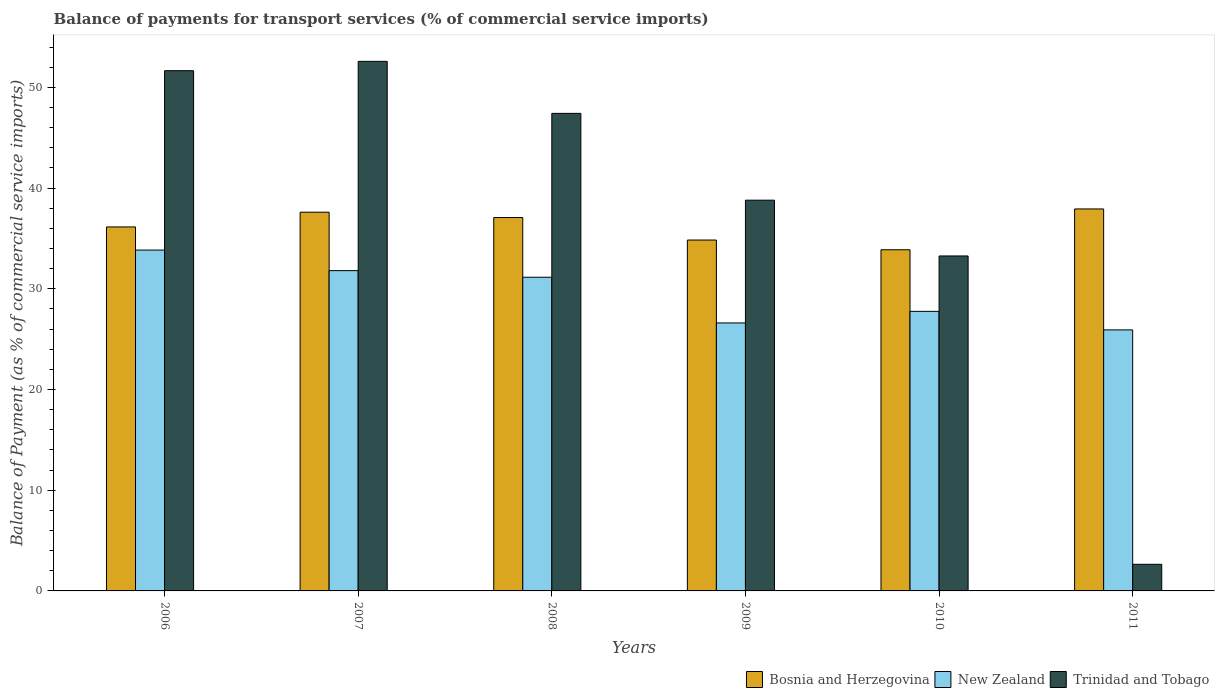How many different coloured bars are there?
Offer a terse response. 3. How many bars are there on the 3rd tick from the left?
Provide a succinct answer. 3. How many bars are there on the 3rd tick from the right?
Your response must be concise. 3. What is the label of the 6th group of bars from the left?
Offer a very short reply. 2011. What is the balance of payments for transport services in Bosnia and Herzegovina in 2010?
Provide a short and direct response. 33.88. Across all years, what is the maximum balance of payments for transport services in New Zealand?
Your response must be concise. 33.85. Across all years, what is the minimum balance of payments for transport services in New Zealand?
Offer a terse response. 25.92. What is the total balance of payments for transport services in New Zealand in the graph?
Offer a very short reply. 177.09. What is the difference between the balance of payments for transport services in New Zealand in 2006 and that in 2010?
Your response must be concise. 6.09. What is the difference between the balance of payments for transport services in New Zealand in 2007 and the balance of payments for transport services in Trinidad and Tobago in 2006?
Your answer should be compact. -19.85. What is the average balance of payments for transport services in Trinidad and Tobago per year?
Provide a succinct answer. 37.73. In the year 2010, what is the difference between the balance of payments for transport services in Trinidad and Tobago and balance of payments for transport services in Bosnia and Herzegovina?
Make the answer very short. -0.61. What is the ratio of the balance of payments for transport services in Bosnia and Herzegovina in 2006 to that in 2011?
Offer a terse response. 0.95. What is the difference between the highest and the second highest balance of payments for transport services in New Zealand?
Your response must be concise. 2.04. What is the difference between the highest and the lowest balance of payments for transport services in Trinidad and Tobago?
Your answer should be very brief. 49.94. Is the sum of the balance of payments for transport services in Trinidad and Tobago in 2007 and 2008 greater than the maximum balance of payments for transport services in Bosnia and Herzegovina across all years?
Your response must be concise. Yes. What does the 2nd bar from the left in 2010 represents?
Give a very brief answer. New Zealand. What does the 1st bar from the right in 2007 represents?
Make the answer very short. Trinidad and Tobago. How many bars are there?
Your answer should be very brief. 18. Are all the bars in the graph horizontal?
Give a very brief answer. No. How many years are there in the graph?
Make the answer very short. 6. Are the values on the major ticks of Y-axis written in scientific E-notation?
Offer a very short reply. No. Does the graph contain grids?
Provide a succinct answer. No. Where does the legend appear in the graph?
Give a very brief answer. Bottom right. How are the legend labels stacked?
Offer a terse response. Horizontal. What is the title of the graph?
Provide a succinct answer. Balance of payments for transport services (% of commercial service imports). What is the label or title of the X-axis?
Keep it short and to the point. Years. What is the label or title of the Y-axis?
Give a very brief answer. Balance of Payment (as % of commercial service imports). What is the Balance of Payment (as % of commercial service imports) in Bosnia and Herzegovina in 2006?
Make the answer very short. 36.14. What is the Balance of Payment (as % of commercial service imports) in New Zealand in 2006?
Ensure brevity in your answer.  33.85. What is the Balance of Payment (as % of commercial service imports) in Trinidad and Tobago in 2006?
Make the answer very short. 51.66. What is the Balance of Payment (as % of commercial service imports) of Bosnia and Herzegovina in 2007?
Your answer should be very brief. 37.6. What is the Balance of Payment (as % of commercial service imports) of New Zealand in 2007?
Offer a terse response. 31.8. What is the Balance of Payment (as % of commercial service imports) of Trinidad and Tobago in 2007?
Provide a short and direct response. 52.58. What is the Balance of Payment (as % of commercial service imports) in Bosnia and Herzegovina in 2008?
Offer a terse response. 37.08. What is the Balance of Payment (as % of commercial service imports) of New Zealand in 2008?
Ensure brevity in your answer.  31.15. What is the Balance of Payment (as % of commercial service imports) of Trinidad and Tobago in 2008?
Provide a succinct answer. 47.42. What is the Balance of Payment (as % of commercial service imports) of Bosnia and Herzegovina in 2009?
Provide a succinct answer. 34.84. What is the Balance of Payment (as % of commercial service imports) in New Zealand in 2009?
Provide a short and direct response. 26.61. What is the Balance of Payment (as % of commercial service imports) of Trinidad and Tobago in 2009?
Make the answer very short. 38.8. What is the Balance of Payment (as % of commercial service imports) of Bosnia and Herzegovina in 2010?
Your answer should be compact. 33.88. What is the Balance of Payment (as % of commercial service imports) of New Zealand in 2010?
Give a very brief answer. 27.76. What is the Balance of Payment (as % of commercial service imports) in Trinidad and Tobago in 2010?
Offer a very short reply. 33.26. What is the Balance of Payment (as % of commercial service imports) of Bosnia and Herzegovina in 2011?
Your response must be concise. 37.93. What is the Balance of Payment (as % of commercial service imports) of New Zealand in 2011?
Ensure brevity in your answer.  25.92. What is the Balance of Payment (as % of commercial service imports) of Trinidad and Tobago in 2011?
Your answer should be very brief. 2.64. Across all years, what is the maximum Balance of Payment (as % of commercial service imports) in Bosnia and Herzegovina?
Offer a very short reply. 37.93. Across all years, what is the maximum Balance of Payment (as % of commercial service imports) of New Zealand?
Make the answer very short. 33.85. Across all years, what is the maximum Balance of Payment (as % of commercial service imports) of Trinidad and Tobago?
Your response must be concise. 52.58. Across all years, what is the minimum Balance of Payment (as % of commercial service imports) in Bosnia and Herzegovina?
Provide a short and direct response. 33.88. Across all years, what is the minimum Balance of Payment (as % of commercial service imports) in New Zealand?
Provide a succinct answer. 25.92. Across all years, what is the minimum Balance of Payment (as % of commercial service imports) of Trinidad and Tobago?
Your answer should be compact. 2.64. What is the total Balance of Payment (as % of commercial service imports) of Bosnia and Herzegovina in the graph?
Your answer should be very brief. 217.47. What is the total Balance of Payment (as % of commercial service imports) in New Zealand in the graph?
Your answer should be very brief. 177.09. What is the total Balance of Payment (as % of commercial service imports) of Trinidad and Tobago in the graph?
Your answer should be compact. 226.37. What is the difference between the Balance of Payment (as % of commercial service imports) of Bosnia and Herzegovina in 2006 and that in 2007?
Your answer should be compact. -1.46. What is the difference between the Balance of Payment (as % of commercial service imports) in New Zealand in 2006 and that in 2007?
Make the answer very short. 2.04. What is the difference between the Balance of Payment (as % of commercial service imports) in Trinidad and Tobago in 2006 and that in 2007?
Keep it short and to the point. -0.93. What is the difference between the Balance of Payment (as % of commercial service imports) of Bosnia and Herzegovina in 2006 and that in 2008?
Keep it short and to the point. -0.93. What is the difference between the Balance of Payment (as % of commercial service imports) of New Zealand in 2006 and that in 2008?
Provide a short and direct response. 2.7. What is the difference between the Balance of Payment (as % of commercial service imports) in Trinidad and Tobago in 2006 and that in 2008?
Offer a terse response. 4.24. What is the difference between the Balance of Payment (as % of commercial service imports) in Bosnia and Herzegovina in 2006 and that in 2009?
Your response must be concise. 1.3. What is the difference between the Balance of Payment (as % of commercial service imports) of New Zealand in 2006 and that in 2009?
Ensure brevity in your answer.  7.24. What is the difference between the Balance of Payment (as % of commercial service imports) in Trinidad and Tobago in 2006 and that in 2009?
Offer a terse response. 12.86. What is the difference between the Balance of Payment (as % of commercial service imports) of Bosnia and Herzegovina in 2006 and that in 2010?
Your answer should be very brief. 2.27. What is the difference between the Balance of Payment (as % of commercial service imports) in New Zealand in 2006 and that in 2010?
Your response must be concise. 6.09. What is the difference between the Balance of Payment (as % of commercial service imports) of Trinidad and Tobago in 2006 and that in 2010?
Provide a short and direct response. 18.4. What is the difference between the Balance of Payment (as % of commercial service imports) in Bosnia and Herzegovina in 2006 and that in 2011?
Keep it short and to the point. -1.79. What is the difference between the Balance of Payment (as % of commercial service imports) of New Zealand in 2006 and that in 2011?
Provide a short and direct response. 7.93. What is the difference between the Balance of Payment (as % of commercial service imports) of Trinidad and Tobago in 2006 and that in 2011?
Your response must be concise. 49.02. What is the difference between the Balance of Payment (as % of commercial service imports) of Bosnia and Herzegovina in 2007 and that in 2008?
Give a very brief answer. 0.53. What is the difference between the Balance of Payment (as % of commercial service imports) of New Zealand in 2007 and that in 2008?
Your response must be concise. 0.66. What is the difference between the Balance of Payment (as % of commercial service imports) in Trinidad and Tobago in 2007 and that in 2008?
Give a very brief answer. 5.16. What is the difference between the Balance of Payment (as % of commercial service imports) of Bosnia and Herzegovina in 2007 and that in 2009?
Ensure brevity in your answer.  2.76. What is the difference between the Balance of Payment (as % of commercial service imports) of New Zealand in 2007 and that in 2009?
Provide a short and direct response. 5.2. What is the difference between the Balance of Payment (as % of commercial service imports) in Trinidad and Tobago in 2007 and that in 2009?
Offer a terse response. 13.79. What is the difference between the Balance of Payment (as % of commercial service imports) in Bosnia and Herzegovina in 2007 and that in 2010?
Give a very brief answer. 3.73. What is the difference between the Balance of Payment (as % of commercial service imports) of New Zealand in 2007 and that in 2010?
Offer a very short reply. 4.04. What is the difference between the Balance of Payment (as % of commercial service imports) in Trinidad and Tobago in 2007 and that in 2010?
Make the answer very short. 19.32. What is the difference between the Balance of Payment (as % of commercial service imports) of Bosnia and Herzegovina in 2007 and that in 2011?
Your response must be concise. -0.32. What is the difference between the Balance of Payment (as % of commercial service imports) of New Zealand in 2007 and that in 2011?
Provide a short and direct response. 5.88. What is the difference between the Balance of Payment (as % of commercial service imports) of Trinidad and Tobago in 2007 and that in 2011?
Provide a short and direct response. 49.94. What is the difference between the Balance of Payment (as % of commercial service imports) in Bosnia and Herzegovina in 2008 and that in 2009?
Your response must be concise. 2.23. What is the difference between the Balance of Payment (as % of commercial service imports) in New Zealand in 2008 and that in 2009?
Your answer should be compact. 4.54. What is the difference between the Balance of Payment (as % of commercial service imports) in Trinidad and Tobago in 2008 and that in 2009?
Make the answer very short. 8.62. What is the difference between the Balance of Payment (as % of commercial service imports) of Bosnia and Herzegovina in 2008 and that in 2010?
Make the answer very short. 3.2. What is the difference between the Balance of Payment (as % of commercial service imports) in New Zealand in 2008 and that in 2010?
Provide a succinct answer. 3.39. What is the difference between the Balance of Payment (as % of commercial service imports) in Trinidad and Tobago in 2008 and that in 2010?
Provide a succinct answer. 14.16. What is the difference between the Balance of Payment (as % of commercial service imports) of Bosnia and Herzegovina in 2008 and that in 2011?
Keep it short and to the point. -0.85. What is the difference between the Balance of Payment (as % of commercial service imports) in New Zealand in 2008 and that in 2011?
Provide a succinct answer. 5.23. What is the difference between the Balance of Payment (as % of commercial service imports) in Trinidad and Tobago in 2008 and that in 2011?
Keep it short and to the point. 44.78. What is the difference between the Balance of Payment (as % of commercial service imports) of Bosnia and Herzegovina in 2009 and that in 2010?
Offer a terse response. 0.97. What is the difference between the Balance of Payment (as % of commercial service imports) in New Zealand in 2009 and that in 2010?
Your answer should be compact. -1.15. What is the difference between the Balance of Payment (as % of commercial service imports) of Trinidad and Tobago in 2009 and that in 2010?
Keep it short and to the point. 5.54. What is the difference between the Balance of Payment (as % of commercial service imports) of Bosnia and Herzegovina in 2009 and that in 2011?
Offer a terse response. -3.09. What is the difference between the Balance of Payment (as % of commercial service imports) of New Zealand in 2009 and that in 2011?
Offer a terse response. 0.69. What is the difference between the Balance of Payment (as % of commercial service imports) in Trinidad and Tobago in 2009 and that in 2011?
Your answer should be very brief. 36.16. What is the difference between the Balance of Payment (as % of commercial service imports) of Bosnia and Herzegovina in 2010 and that in 2011?
Provide a short and direct response. -4.05. What is the difference between the Balance of Payment (as % of commercial service imports) in New Zealand in 2010 and that in 2011?
Offer a very short reply. 1.84. What is the difference between the Balance of Payment (as % of commercial service imports) of Trinidad and Tobago in 2010 and that in 2011?
Give a very brief answer. 30.62. What is the difference between the Balance of Payment (as % of commercial service imports) in Bosnia and Herzegovina in 2006 and the Balance of Payment (as % of commercial service imports) in New Zealand in 2007?
Your answer should be compact. 4.34. What is the difference between the Balance of Payment (as % of commercial service imports) in Bosnia and Herzegovina in 2006 and the Balance of Payment (as % of commercial service imports) in Trinidad and Tobago in 2007?
Your response must be concise. -16.44. What is the difference between the Balance of Payment (as % of commercial service imports) in New Zealand in 2006 and the Balance of Payment (as % of commercial service imports) in Trinidad and Tobago in 2007?
Give a very brief answer. -18.74. What is the difference between the Balance of Payment (as % of commercial service imports) in Bosnia and Herzegovina in 2006 and the Balance of Payment (as % of commercial service imports) in New Zealand in 2008?
Provide a succinct answer. 5. What is the difference between the Balance of Payment (as % of commercial service imports) of Bosnia and Herzegovina in 2006 and the Balance of Payment (as % of commercial service imports) of Trinidad and Tobago in 2008?
Ensure brevity in your answer.  -11.28. What is the difference between the Balance of Payment (as % of commercial service imports) of New Zealand in 2006 and the Balance of Payment (as % of commercial service imports) of Trinidad and Tobago in 2008?
Provide a short and direct response. -13.57. What is the difference between the Balance of Payment (as % of commercial service imports) of Bosnia and Herzegovina in 2006 and the Balance of Payment (as % of commercial service imports) of New Zealand in 2009?
Offer a terse response. 9.53. What is the difference between the Balance of Payment (as % of commercial service imports) of Bosnia and Herzegovina in 2006 and the Balance of Payment (as % of commercial service imports) of Trinidad and Tobago in 2009?
Provide a short and direct response. -2.66. What is the difference between the Balance of Payment (as % of commercial service imports) in New Zealand in 2006 and the Balance of Payment (as % of commercial service imports) in Trinidad and Tobago in 2009?
Make the answer very short. -4.95. What is the difference between the Balance of Payment (as % of commercial service imports) of Bosnia and Herzegovina in 2006 and the Balance of Payment (as % of commercial service imports) of New Zealand in 2010?
Provide a succinct answer. 8.38. What is the difference between the Balance of Payment (as % of commercial service imports) of Bosnia and Herzegovina in 2006 and the Balance of Payment (as % of commercial service imports) of Trinidad and Tobago in 2010?
Keep it short and to the point. 2.88. What is the difference between the Balance of Payment (as % of commercial service imports) in New Zealand in 2006 and the Balance of Payment (as % of commercial service imports) in Trinidad and Tobago in 2010?
Make the answer very short. 0.58. What is the difference between the Balance of Payment (as % of commercial service imports) of Bosnia and Herzegovina in 2006 and the Balance of Payment (as % of commercial service imports) of New Zealand in 2011?
Give a very brief answer. 10.22. What is the difference between the Balance of Payment (as % of commercial service imports) of Bosnia and Herzegovina in 2006 and the Balance of Payment (as % of commercial service imports) of Trinidad and Tobago in 2011?
Your response must be concise. 33.5. What is the difference between the Balance of Payment (as % of commercial service imports) in New Zealand in 2006 and the Balance of Payment (as % of commercial service imports) in Trinidad and Tobago in 2011?
Offer a terse response. 31.2. What is the difference between the Balance of Payment (as % of commercial service imports) in Bosnia and Herzegovina in 2007 and the Balance of Payment (as % of commercial service imports) in New Zealand in 2008?
Give a very brief answer. 6.46. What is the difference between the Balance of Payment (as % of commercial service imports) of Bosnia and Herzegovina in 2007 and the Balance of Payment (as % of commercial service imports) of Trinidad and Tobago in 2008?
Offer a terse response. -9.82. What is the difference between the Balance of Payment (as % of commercial service imports) of New Zealand in 2007 and the Balance of Payment (as % of commercial service imports) of Trinidad and Tobago in 2008?
Ensure brevity in your answer.  -15.62. What is the difference between the Balance of Payment (as % of commercial service imports) of Bosnia and Herzegovina in 2007 and the Balance of Payment (as % of commercial service imports) of New Zealand in 2009?
Your answer should be very brief. 11. What is the difference between the Balance of Payment (as % of commercial service imports) of Bosnia and Herzegovina in 2007 and the Balance of Payment (as % of commercial service imports) of Trinidad and Tobago in 2009?
Provide a short and direct response. -1.19. What is the difference between the Balance of Payment (as % of commercial service imports) in New Zealand in 2007 and the Balance of Payment (as % of commercial service imports) in Trinidad and Tobago in 2009?
Give a very brief answer. -6.99. What is the difference between the Balance of Payment (as % of commercial service imports) of Bosnia and Herzegovina in 2007 and the Balance of Payment (as % of commercial service imports) of New Zealand in 2010?
Your answer should be very brief. 9.84. What is the difference between the Balance of Payment (as % of commercial service imports) in Bosnia and Herzegovina in 2007 and the Balance of Payment (as % of commercial service imports) in Trinidad and Tobago in 2010?
Give a very brief answer. 4.34. What is the difference between the Balance of Payment (as % of commercial service imports) in New Zealand in 2007 and the Balance of Payment (as % of commercial service imports) in Trinidad and Tobago in 2010?
Your answer should be very brief. -1.46. What is the difference between the Balance of Payment (as % of commercial service imports) in Bosnia and Herzegovina in 2007 and the Balance of Payment (as % of commercial service imports) in New Zealand in 2011?
Your answer should be very brief. 11.68. What is the difference between the Balance of Payment (as % of commercial service imports) in Bosnia and Herzegovina in 2007 and the Balance of Payment (as % of commercial service imports) in Trinidad and Tobago in 2011?
Make the answer very short. 34.96. What is the difference between the Balance of Payment (as % of commercial service imports) of New Zealand in 2007 and the Balance of Payment (as % of commercial service imports) of Trinidad and Tobago in 2011?
Provide a succinct answer. 29.16. What is the difference between the Balance of Payment (as % of commercial service imports) of Bosnia and Herzegovina in 2008 and the Balance of Payment (as % of commercial service imports) of New Zealand in 2009?
Ensure brevity in your answer.  10.47. What is the difference between the Balance of Payment (as % of commercial service imports) in Bosnia and Herzegovina in 2008 and the Balance of Payment (as % of commercial service imports) in Trinidad and Tobago in 2009?
Your response must be concise. -1.72. What is the difference between the Balance of Payment (as % of commercial service imports) in New Zealand in 2008 and the Balance of Payment (as % of commercial service imports) in Trinidad and Tobago in 2009?
Provide a short and direct response. -7.65. What is the difference between the Balance of Payment (as % of commercial service imports) of Bosnia and Herzegovina in 2008 and the Balance of Payment (as % of commercial service imports) of New Zealand in 2010?
Give a very brief answer. 9.31. What is the difference between the Balance of Payment (as % of commercial service imports) in Bosnia and Herzegovina in 2008 and the Balance of Payment (as % of commercial service imports) in Trinidad and Tobago in 2010?
Provide a succinct answer. 3.81. What is the difference between the Balance of Payment (as % of commercial service imports) in New Zealand in 2008 and the Balance of Payment (as % of commercial service imports) in Trinidad and Tobago in 2010?
Ensure brevity in your answer.  -2.11. What is the difference between the Balance of Payment (as % of commercial service imports) in Bosnia and Herzegovina in 2008 and the Balance of Payment (as % of commercial service imports) in New Zealand in 2011?
Ensure brevity in your answer.  11.16. What is the difference between the Balance of Payment (as % of commercial service imports) in Bosnia and Herzegovina in 2008 and the Balance of Payment (as % of commercial service imports) in Trinidad and Tobago in 2011?
Provide a short and direct response. 34.43. What is the difference between the Balance of Payment (as % of commercial service imports) of New Zealand in 2008 and the Balance of Payment (as % of commercial service imports) of Trinidad and Tobago in 2011?
Offer a terse response. 28.51. What is the difference between the Balance of Payment (as % of commercial service imports) in Bosnia and Herzegovina in 2009 and the Balance of Payment (as % of commercial service imports) in New Zealand in 2010?
Keep it short and to the point. 7.08. What is the difference between the Balance of Payment (as % of commercial service imports) of Bosnia and Herzegovina in 2009 and the Balance of Payment (as % of commercial service imports) of Trinidad and Tobago in 2010?
Give a very brief answer. 1.58. What is the difference between the Balance of Payment (as % of commercial service imports) of New Zealand in 2009 and the Balance of Payment (as % of commercial service imports) of Trinidad and Tobago in 2010?
Make the answer very short. -6.65. What is the difference between the Balance of Payment (as % of commercial service imports) in Bosnia and Herzegovina in 2009 and the Balance of Payment (as % of commercial service imports) in New Zealand in 2011?
Offer a terse response. 8.92. What is the difference between the Balance of Payment (as % of commercial service imports) in Bosnia and Herzegovina in 2009 and the Balance of Payment (as % of commercial service imports) in Trinidad and Tobago in 2011?
Keep it short and to the point. 32.2. What is the difference between the Balance of Payment (as % of commercial service imports) of New Zealand in 2009 and the Balance of Payment (as % of commercial service imports) of Trinidad and Tobago in 2011?
Offer a very short reply. 23.97. What is the difference between the Balance of Payment (as % of commercial service imports) of Bosnia and Herzegovina in 2010 and the Balance of Payment (as % of commercial service imports) of New Zealand in 2011?
Provide a short and direct response. 7.96. What is the difference between the Balance of Payment (as % of commercial service imports) of Bosnia and Herzegovina in 2010 and the Balance of Payment (as % of commercial service imports) of Trinidad and Tobago in 2011?
Keep it short and to the point. 31.23. What is the difference between the Balance of Payment (as % of commercial service imports) of New Zealand in 2010 and the Balance of Payment (as % of commercial service imports) of Trinidad and Tobago in 2011?
Ensure brevity in your answer.  25.12. What is the average Balance of Payment (as % of commercial service imports) of Bosnia and Herzegovina per year?
Your answer should be very brief. 36.25. What is the average Balance of Payment (as % of commercial service imports) in New Zealand per year?
Ensure brevity in your answer.  29.51. What is the average Balance of Payment (as % of commercial service imports) of Trinidad and Tobago per year?
Make the answer very short. 37.73. In the year 2006, what is the difference between the Balance of Payment (as % of commercial service imports) of Bosnia and Herzegovina and Balance of Payment (as % of commercial service imports) of New Zealand?
Keep it short and to the point. 2.3. In the year 2006, what is the difference between the Balance of Payment (as % of commercial service imports) in Bosnia and Herzegovina and Balance of Payment (as % of commercial service imports) in Trinidad and Tobago?
Ensure brevity in your answer.  -15.51. In the year 2006, what is the difference between the Balance of Payment (as % of commercial service imports) in New Zealand and Balance of Payment (as % of commercial service imports) in Trinidad and Tobago?
Keep it short and to the point. -17.81. In the year 2007, what is the difference between the Balance of Payment (as % of commercial service imports) in Bosnia and Herzegovina and Balance of Payment (as % of commercial service imports) in New Zealand?
Your response must be concise. 5.8. In the year 2007, what is the difference between the Balance of Payment (as % of commercial service imports) of Bosnia and Herzegovina and Balance of Payment (as % of commercial service imports) of Trinidad and Tobago?
Provide a succinct answer. -14.98. In the year 2007, what is the difference between the Balance of Payment (as % of commercial service imports) in New Zealand and Balance of Payment (as % of commercial service imports) in Trinidad and Tobago?
Ensure brevity in your answer.  -20.78. In the year 2008, what is the difference between the Balance of Payment (as % of commercial service imports) in Bosnia and Herzegovina and Balance of Payment (as % of commercial service imports) in New Zealand?
Your answer should be very brief. 5.93. In the year 2008, what is the difference between the Balance of Payment (as % of commercial service imports) in Bosnia and Herzegovina and Balance of Payment (as % of commercial service imports) in Trinidad and Tobago?
Your response must be concise. -10.35. In the year 2008, what is the difference between the Balance of Payment (as % of commercial service imports) in New Zealand and Balance of Payment (as % of commercial service imports) in Trinidad and Tobago?
Offer a very short reply. -16.27. In the year 2009, what is the difference between the Balance of Payment (as % of commercial service imports) of Bosnia and Herzegovina and Balance of Payment (as % of commercial service imports) of New Zealand?
Offer a very short reply. 8.23. In the year 2009, what is the difference between the Balance of Payment (as % of commercial service imports) in Bosnia and Herzegovina and Balance of Payment (as % of commercial service imports) in Trinidad and Tobago?
Keep it short and to the point. -3.96. In the year 2009, what is the difference between the Balance of Payment (as % of commercial service imports) in New Zealand and Balance of Payment (as % of commercial service imports) in Trinidad and Tobago?
Offer a very short reply. -12.19. In the year 2010, what is the difference between the Balance of Payment (as % of commercial service imports) in Bosnia and Herzegovina and Balance of Payment (as % of commercial service imports) in New Zealand?
Your answer should be very brief. 6.12. In the year 2010, what is the difference between the Balance of Payment (as % of commercial service imports) of Bosnia and Herzegovina and Balance of Payment (as % of commercial service imports) of Trinidad and Tobago?
Offer a terse response. 0.61. In the year 2010, what is the difference between the Balance of Payment (as % of commercial service imports) of New Zealand and Balance of Payment (as % of commercial service imports) of Trinidad and Tobago?
Provide a succinct answer. -5.5. In the year 2011, what is the difference between the Balance of Payment (as % of commercial service imports) of Bosnia and Herzegovina and Balance of Payment (as % of commercial service imports) of New Zealand?
Offer a terse response. 12.01. In the year 2011, what is the difference between the Balance of Payment (as % of commercial service imports) of Bosnia and Herzegovina and Balance of Payment (as % of commercial service imports) of Trinidad and Tobago?
Ensure brevity in your answer.  35.29. In the year 2011, what is the difference between the Balance of Payment (as % of commercial service imports) in New Zealand and Balance of Payment (as % of commercial service imports) in Trinidad and Tobago?
Ensure brevity in your answer.  23.28. What is the ratio of the Balance of Payment (as % of commercial service imports) of Bosnia and Herzegovina in 2006 to that in 2007?
Keep it short and to the point. 0.96. What is the ratio of the Balance of Payment (as % of commercial service imports) of New Zealand in 2006 to that in 2007?
Give a very brief answer. 1.06. What is the ratio of the Balance of Payment (as % of commercial service imports) in Trinidad and Tobago in 2006 to that in 2007?
Your response must be concise. 0.98. What is the ratio of the Balance of Payment (as % of commercial service imports) in Bosnia and Herzegovina in 2006 to that in 2008?
Your response must be concise. 0.97. What is the ratio of the Balance of Payment (as % of commercial service imports) of New Zealand in 2006 to that in 2008?
Offer a very short reply. 1.09. What is the ratio of the Balance of Payment (as % of commercial service imports) of Trinidad and Tobago in 2006 to that in 2008?
Make the answer very short. 1.09. What is the ratio of the Balance of Payment (as % of commercial service imports) in Bosnia and Herzegovina in 2006 to that in 2009?
Give a very brief answer. 1.04. What is the ratio of the Balance of Payment (as % of commercial service imports) of New Zealand in 2006 to that in 2009?
Offer a terse response. 1.27. What is the ratio of the Balance of Payment (as % of commercial service imports) in Trinidad and Tobago in 2006 to that in 2009?
Keep it short and to the point. 1.33. What is the ratio of the Balance of Payment (as % of commercial service imports) of Bosnia and Herzegovina in 2006 to that in 2010?
Your answer should be very brief. 1.07. What is the ratio of the Balance of Payment (as % of commercial service imports) in New Zealand in 2006 to that in 2010?
Make the answer very short. 1.22. What is the ratio of the Balance of Payment (as % of commercial service imports) of Trinidad and Tobago in 2006 to that in 2010?
Offer a terse response. 1.55. What is the ratio of the Balance of Payment (as % of commercial service imports) of Bosnia and Herzegovina in 2006 to that in 2011?
Your answer should be very brief. 0.95. What is the ratio of the Balance of Payment (as % of commercial service imports) of New Zealand in 2006 to that in 2011?
Your answer should be compact. 1.31. What is the ratio of the Balance of Payment (as % of commercial service imports) of Trinidad and Tobago in 2006 to that in 2011?
Keep it short and to the point. 19.55. What is the ratio of the Balance of Payment (as % of commercial service imports) of Bosnia and Herzegovina in 2007 to that in 2008?
Ensure brevity in your answer.  1.01. What is the ratio of the Balance of Payment (as % of commercial service imports) in New Zealand in 2007 to that in 2008?
Keep it short and to the point. 1.02. What is the ratio of the Balance of Payment (as % of commercial service imports) in Trinidad and Tobago in 2007 to that in 2008?
Your answer should be compact. 1.11. What is the ratio of the Balance of Payment (as % of commercial service imports) in Bosnia and Herzegovina in 2007 to that in 2009?
Provide a short and direct response. 1.08. What is the ratio of the Balance of Payment (as % of commercial service imports) in New Zealand in 2007 to that in 2009?
Offer a very short reply. 1.2. What is the ratio of the Balance of Payment (as % of commercial service imports) of Trinidad and Tobago in 2007 to that in 2009?
Offer a terse response. 1.36. What is the ratio of the Balance of Payment (as % of commercial service imports) of Bosnia and Herzegovina in 2007 to that in 2010?
Offer a very short reply. 1.11. What is the ratio of the Balance of Payment (as % of commercial service imports) of New Zealand in 2007 to that in 2010?
Give a very brief answer. 1.15. What is the ratio of the Balance of Payment (as % of commercial service imports) of Trinidad and Tobago in 2007 to that in 2010?
Make the answer very short. 1.58. What is the ratio of the Balance of Payment (as % of commercial service imports) of Bosnia and Herzegovina in 2007 to that in 2011?
Make the answer very short. 0.99. What is the ratio of the Balance of Payment (as % of commercial service imports) in New Zealand in 2007 to that in 2011?
Your answer should be very brief. 1.23. What is the ratio of the Balance of Payment (as % of commercial service imports) of Trinidad and Tobago in 2007 to that in 2011?
Your response must be concise. 19.9. What is the ratio of the Balance of Payment (as % of commercial service imports) of Bosnia and Herzegovina in 2008 to that in 2009?
Your answer should be compact. 1.06. What is the ratio of the Balance of Payment (as % of commercial service imports) in New Zealand in 2008 to that in 2009?
Offer a terse response. 1.17. What is the ratio of the Balance of Payment (as % of commercial service imports) of Trinidad and Tobago in 2008 to that in 2009?
Give a very brief answer. 1.22. What is the ratio of the Balance of Payment (as % of commercial service imports) in Bosnia and Herzegovina in 2008 to that in 2010?
Give a very brief answer. 1.09. What is the ratio of the Balance of Payment (as % of commercial service imports) in New Zealand in 2008 to that in 2010?
Keep it short and to the point. 1.12. What is the ratio of the Balance of Payment (as % of commercial service imports) in Trinidad and Tobago in 2008 to that in 2010?
Ensure brevity in your answer.  1.43. What is the ratio of the Balance of Payment (as % of commercial service imports) of Bosnia and Herzegovina in 2008 to that in 2011?
Your response must be concise. 0.98. What is the ratio of the Balance of Payment (as % of commercial service imports) of New Zealand in 2008 to that in 2011?
Your response must be concise. 1.2. What is the ratio of the Balance of Payment (as % of commercial service imports) in Trinidad and Tobago in 2008 to that in 2011?
Keep it short and to the point. 17.95. What is the ratio of the Balance of Payment (as % of commercial service imports) in Bosnia and Herzegovina in 2009 to that in 2010?
Provide a succinct answer. 1.03. What is the ratio of the Balance of Payment (as % of commercial service imports) of New Zealand in 2009 to that in 2010?
Offer a very short reply. 0.96. What is the ratio of the Balance of Payment (as % of commercial service imports) in Trinidad and Tobago in 2009 to that in 2010?
Your answer should be very brief. 1.17. What is the ratio of the Balance of Payment (as % of commercial service imports) of Bosnia and Herzegovina in 2009 to that in 2011?
Make the answer very short. 0.92. What is the ratio of the Balance of Payment (as % of commercial service imports) in New Zealand in 2009 to that in 2011?
Offer a very short reply. 1.03. What is the ratio of the Balance of Payment (as % of commercial service imports) of Trinidad and Tobago in 2009 to that in 2011?
Keep it short and to the point. 14.68. What is the ratio of the Balance of Payment (as % of commercial service imports) in Bosnia and Herzegovina in 2010 to that in 2011?
Make the answer very short. 0.89. What is the ratio of the Balance of Payment (as % of commercial service imports) in New Zealand in 2010 to that in 2011?
Ensure brevity in your answer.  1.07. What is the ratio of the Balance of Payment (as % of commercial service imports) of Trinidad and Tobago in 2010 to that in 2011?
Your answer should be compact. 12.59. What is the difference between the highest and the second highest Balance of Payment (as % of commercial service imports) of Bosnia and Herzegovina?
Offer a terse response. 0.32. What is the difference between the highest and the second highest Balance of Payment (as % of commercial service imports) in New Zealand?
Make the answer very short. 2.04. What is the difference between the highest and the second highest Balance of Payment (as % of commercial service imports) of Trinidad and Tobago?
Provide a succinct answer. 0.93. What is the difference between the highest and the lowest Balance of Payment (as % of commercial service imports) in Bosnia and Herzegovina?
Give a very brief answer. 4.05. What is the difference between the highest and the lowest Balance of Payment (as % of commercial service imports) in New Zealand?
Give a very brief answer. 7.93. What is the difference between the highest and the lowest Balance of Payment (as % of commercial service imports) of Trinidad and Tobago?
Your answer should be very brief. 49.94. 